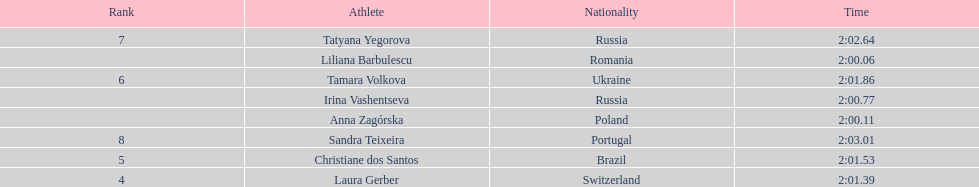What is the number of russian participants in this set of semifinals? 2. 